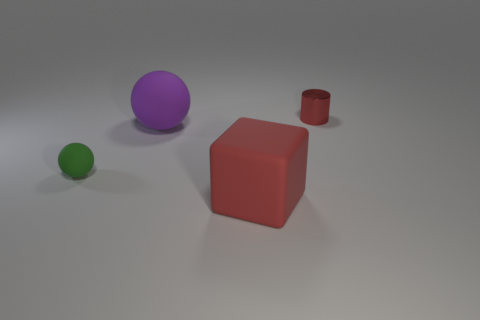Is the number of tiny red objects greater than the number of green rubber cylinders?
Make the answer very short. Yes. What number of metallic cylinders are the same size as the rubber block?
Ensure brevity in your answer.  0. There is a small metallic thing that is the same color as the big cube; what is its shape?
Keep it short and to the point. Cylinder. What number of objects are either red things that are behind the red block or big blue rubber things?
Offer a terse response. 1. Is the number of things less than the number of large green objects?
Your answer should be compact. No. The red thing that is the same material as the purple sphere is what shape?
Offer a terse response. Cube. There is a small rubber sphere; are there any tiny cylinders in front of it?
Make the answer very short. No. Is the number of red cylinders that are to the left of the small green rubber ball less than the number of big matte balls?
Your response must be concise. Yes. What material is the red block?
Provide a succinct answer. Rubber. The metallic thing is what color?
Your answer should be compact. Red. 